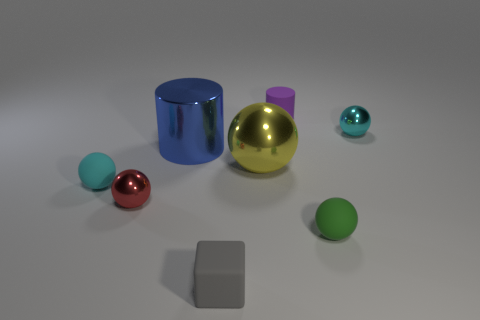Could you tell me about the metallic sphere? Certainly! The metallic sphere in the image has a reflective gold finish, exhibiting high gloss and mirroring its surroundings to some extent. Its shiny appearance makes it stand out among the other objects. 